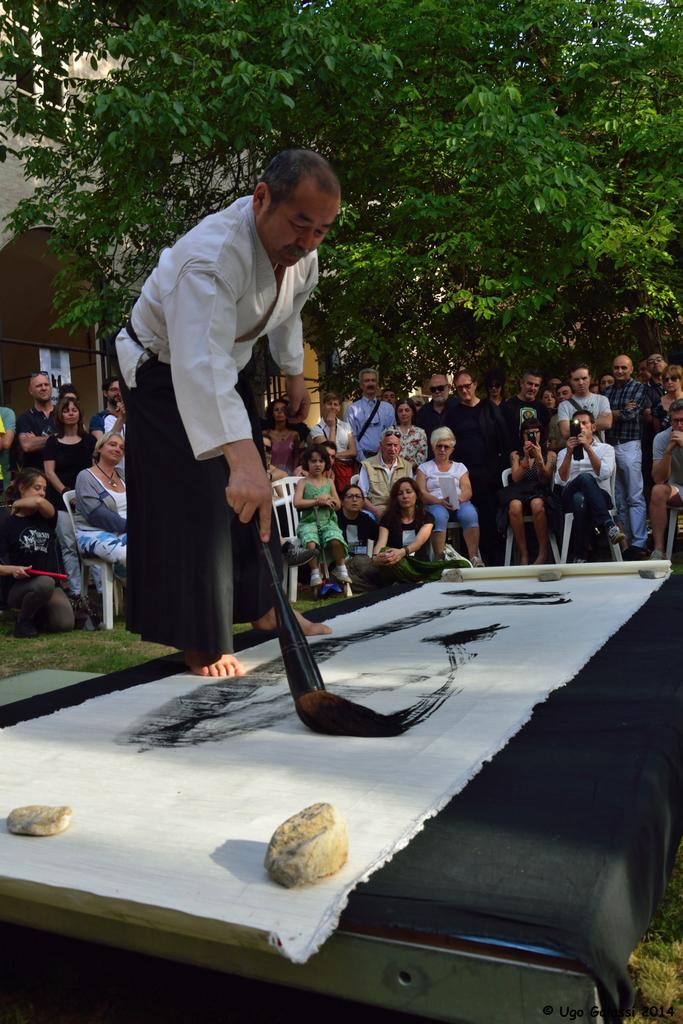What is the man in the image doing? The man is painting on a sheet. What tool is the man using for his painting? The man is using a brush. What can be seen in the foreground of the image? There are stones visible in the image. What is present in the image besides the man and his painting materials? There is a cloth in the image. What can be seen in the background of the image? There are people, grass, a house, and trees visible in the background of the image. How many attempts did the family make to steal the crook's hat in the image? There is no family or crook present in the image, and therefore no such activity can be observed. 